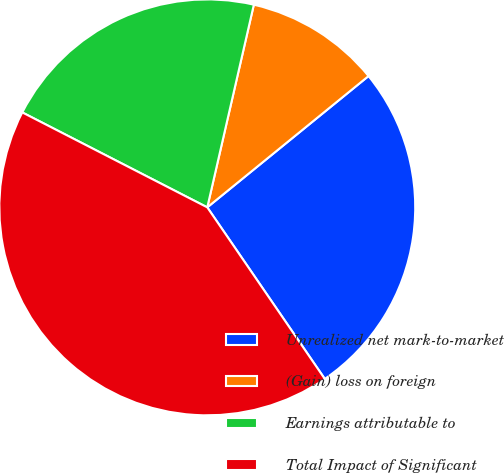Convert chart. <chart><loc_0><loc_0><loc_500><loc_500><pie_chart><fcel>Unrealized net mark-to-market<fcel>(Gain) loss on foreign<fcel>Earnings attributable to<fcel>Total Impact of Significant<nl><fcel>26.32%<fcel>10.53%<fcel>21.05%<fcel>42.11%<nl></chart> 